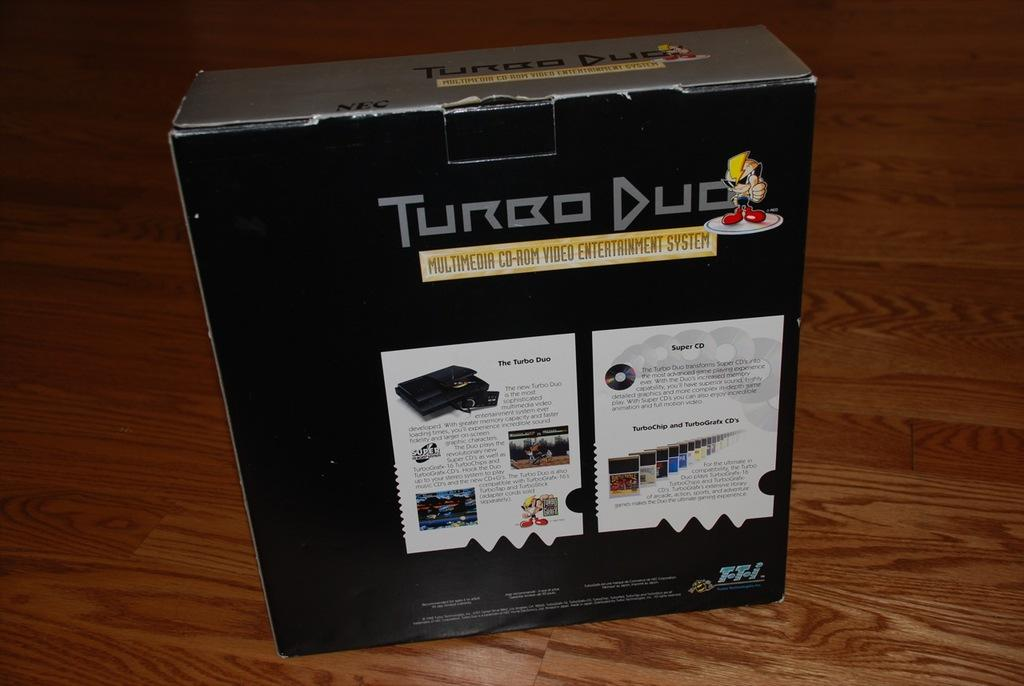<image>
Give a short and clear explanation of the subsequent image. the words turbo duck on a black item 